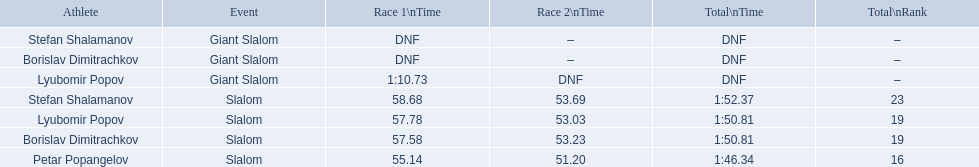What are the contests lyubomir popov participated in? Lyubomir Popov, Lyubomir Popov. Among them, which ones were giant slalom events? Giant Slalom. What was his duration in the first race? 1:10.73. 